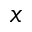Convert formula to latex. <formula><loc_0><loc_0><loc_500><loc_500>x</formula> 